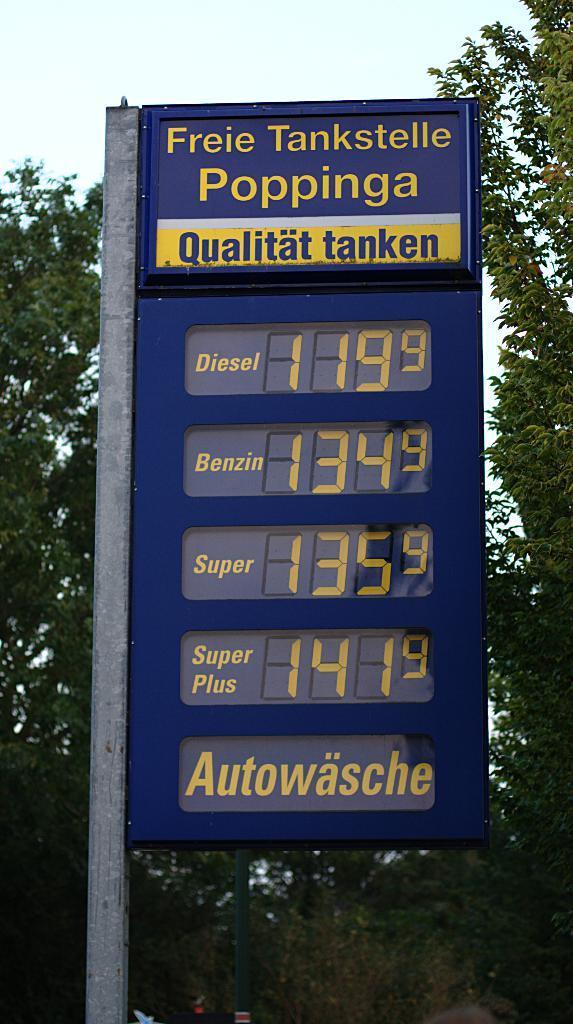Describe this image in one or two sentences. In this image, we can see a blue color digital price board, we can see some trees and at the top there is a sky. 